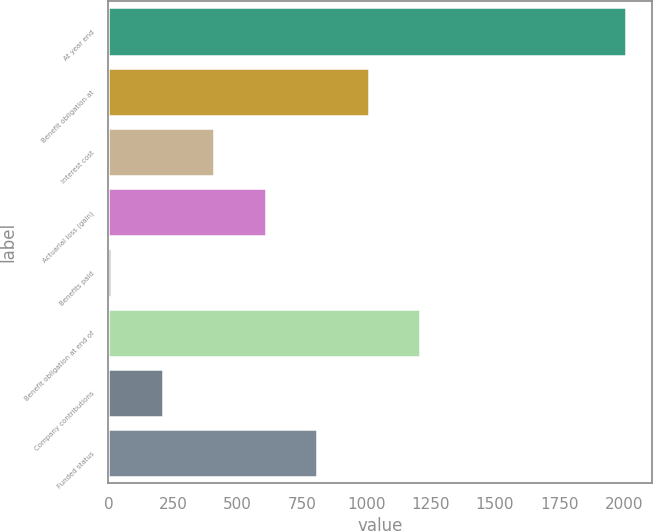<chart> <loc_0><loc_0><loc_500><loc_500><bar_chart><fcel>At year end<fcel>Benefit obligation at<fcel>Interest cost<fcel>Actuarial loss (gain)<fcel>Benefits paid<fcel>Benefit obligation at end of<fcel>Company contributions<fcel>Funded status<nl><fcel>2009<fcel>1009.5<fcel>409.8<fcel>609.7<fcel>10<fcel>1209.4<fcel>209.9<fcel>809.6<nl></chart> 